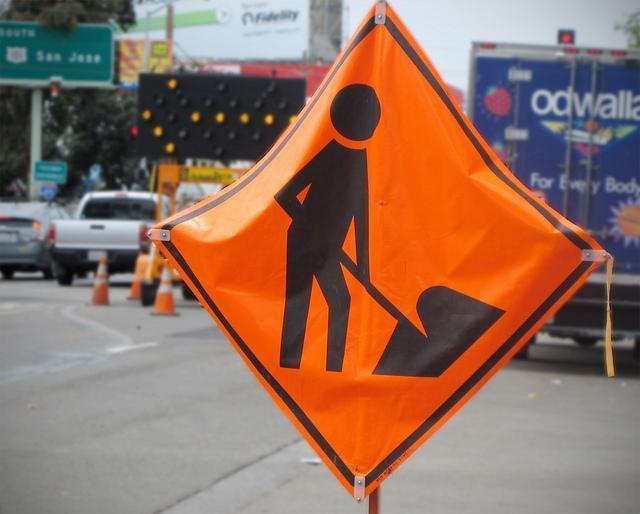What does the orange sign alert drivers of?
Select the accurate answer and provide justification: `Answer: choice
Rationale: srationale.`
Options: Turns prohibited, bike lanes, animal crossing, construction. Answer: construction.
Rationale: The sign is used to showcase visually that work is being done by having a silhouette of a man digging. 